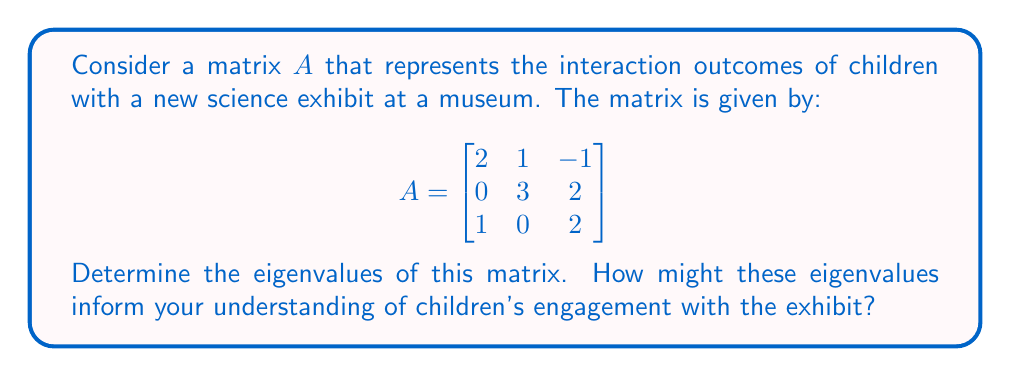Could you help me with this problem? To find the eigenvalues of matrix $A$, we need to solve the characteristic equation:

1) First, we calculate $det(A - \lambda I)$, where $I$ is the 3x3 identity matrix:

   $$det(A - \lambda I) = det\begin{bmatrix}
   2-\lambda & 1 & -1 \\
   0 & 3-\lambda & 2 \\
   1 & 0 & 2-\lambda
   \end{bmatrix}$$

2) Expanding this determinant:
   
   $$(2-\lambda)[(3-\lambda)(2-\lambda) - 0] + 1[0 - (-1)(3-\lambda)] + (-1)[0 - 2]$$
   
   $$(2-\lambda)(6-5\lambda+\lambda^2) + (3-\lambda) + 2$$

3) Simplifying:

   $$12-10\lambda+2\lambda^2-6\lambda+5\lambda^2-\lambda^3 + 3 - \lambda + 2$$
   
   $$-\lambda^3 + 7\lambda^2 - 17\lambda + 17 = 0$$

4) This is the characteristic equation. To solve it, we can factor out $(\lambda - 2)$:

   $$(\lambda - 2)(-\lambda^2 + 5\lambda - 7) = 0$$

5) Using the quadratic formula for $-\lambda^2 + 5\lambda - 7 = 0$:

   $$\lambda = \frac{-5 \pm \sqrt{25 - 28}}{-2} = \frac{-5 \pm \sqrt{-3}}{-2}$$

Therefore, the eigenvalues are:
$\lambda_1 = 2$, $\lambda_2 = \frac{5 + i\sqrt{3}}{2}$, $\lambda_3 = \frac{5 - i\sqrt{3}}{2}$

In the context of children's engagement with the exhibit:
- The real eigenvalue (2) might represent a stable mode of interaction.
- The complex eigenvalues suggest oscillatory behavior, which could indicate varying levels of engagement or cyclical patterns in children's interactions with the exhibit.
- The magnitude of the eigenvalues (all greater than 1) might suggest that the exhibit is generally stimulating and encourages increased engagement over time.
Answer: The eigenvalues of the matrix $A$ are:
$\lambda_1 = 2$, $\lambda_2 = \frac{5 + i\sqrt{3}}{2}$, $\lambda_3 = \frac{5 - i\sqrt{3}}{2}$ 